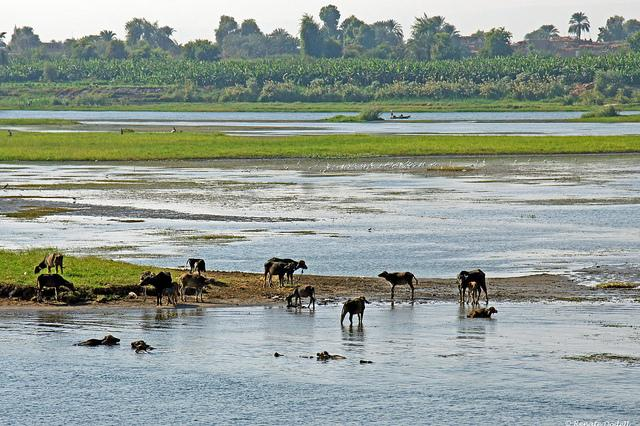What are the animals called? Please explain your reasoning. wildebeests. Large brown animals with horns and hooves are grazing and drinking in an savannah type area. 